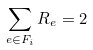<formula> <loc_0><loc_0><loc_500><loc_500>\sum _ { e \in F _ { i } } R _ { e } = 2</formula> 